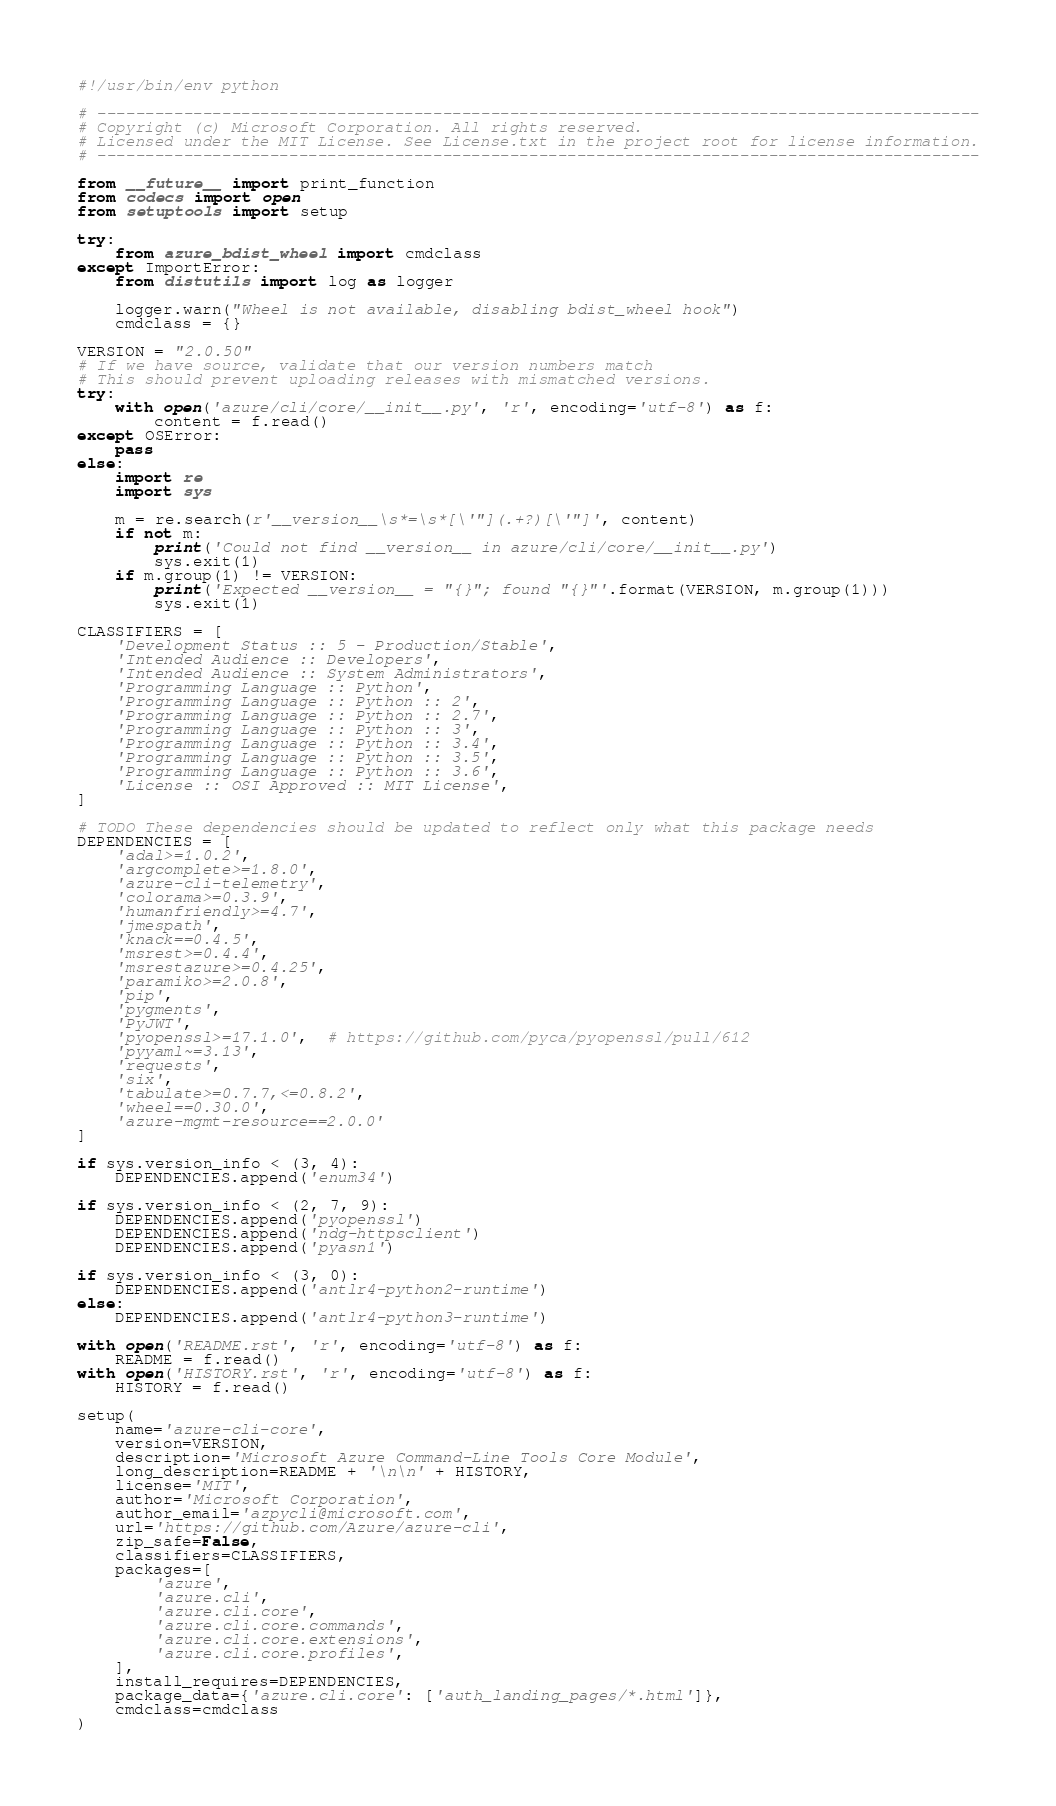<code> <loc_0><loc_0><loc_500><loc_500><_Python_>#!/usr/bin/env python

# --------------------------------------------------------------------------------------------
# Copyright (c) Microsoft Corporation. All rights reserved.
# Licensed under the MIT License. See License.txt in the project root for license information.
# --------------------------------------------------------------------------------------------

from __future__ import print_function
from codecs import open
from setuptools import setup

try:
    from azure_bdist_wheel import cmdclass
except ImportError:
    from distutils import log as logger

    logger.warn("Wheel is not available, disabling bdist_wheel hook")
    cmdclass = {}

VERSION = "2.0.50"
# If we have source, validate that our version numbers match
# This should prevent uploading releases with mismatched versions.
try:
    with open('azure/cli/core/__init__.py', 'r', encoding='utf-8') as f:
        content = f.read()
except OSError:
    pass
else:
    import re
    import sys

    m = re.search(r'__version__\s*=\s*[\'"](.+?)[\'"]', content)
    if not m:
        print('Could not find __version__ in azure/cli/core/__init__.py')
        sys.exit(1)
    if m.group(1) != VERSION:
        print('Expected __version__ = "{}"; found "{}"'.format(VERSION, m.group(1)))
        sys.exit(1)

CLASSIFIERS = [
    'Development Status :: 5 - Production/Stable',
    'Intended Audience :: Developers',
    'Intended Audience :: System Administrators',
    'Programming Language :: Python',
    'Programming Language :: Python :: 2',
    'Programming Language :: Python :: 2.7',
    'Programming Language :: Python :: 3',
    'Programming Language :: Python :: 3.4',
    'Programming Language :: Python :: 3.5',
    'Programming Language :: Python :: 3.6',
    'License :: OSI Approved :: MIT License',
]

# TODO These dependencies should be updated to reflect only what this package needs
DEPENDENCIES = [
    'adal>=1.0.2',
    'argcomplete>=1.8.0',
    'azure-cli-telemetry',
    'colorama>=0.3.9',
    'humanfriendly>=4.7',
    'jmespath',
    'knack==0.4.5',
    'msrest>=0.4.4',
    'msrestazure>=0.4.25',
    'paramiko>=2.0.8',
    'pip',
    'pygments',
    'PyJWT',
    'pyopenssl>=17.1.0',  # https://github.com/pyca/pyopenssl/pull/612
    'pyyaml~=3.13',
    'requests',
    'six',
    'tabulate>=0.7.7,<=0.8.2',
    'wheel==0.30.0',
    'azure-mgmt-resource==2.0.0'
]

if sys.version_info < (3, 4):
    DEPENDENCIES.append('enum34')

if sys.version_info < (2, 7, 9):
    DEPENDENCIES.append('pyopenssl')
    DEPENDENCIES.append('ndg-httpsclient')
    DEPENDENCIES.append('pyasn1')

if sys.version_info < (3, 0):
    DEPENDENCIES.append('antlr4-python2-runtime')
else:
    DEPENDENCIES.append('antlr4-python3-runtime')

with open('README.rst', 'r', encoding='utf-8') as f:
    README = f.read()
with open('HISTORY.rst', 'r', encoding='utf-8') as f:
    HISTORY = f.read()

setup(
    name='azure-cli-core',
    version=VERSION,
    description='Microsoft Azure Command-Line Tools Core Module',
    long_description=README + '\n\n' + HISTORY,
    license='MIT',
    author='Microsoft Corporation',
    author_email='azpycli@microsoft.com',
    url='https://github.com/Azure/azure-cli',
    zip_safe=False,
    classifiers=CLASSIFIERS,
    packages=[
        'azure',
        'azure.cli',
        'azure.cli.core',
        'azure.cli.core.commands',
        'azure.cli.core.extensions',
        'azure.cli.core.profiles',
    ],
    install_requires=DEPENDENCIES,
    package_data={'azure.cli.core': ['auth_landing_pages/*.html']},
    cmdclass=cmdclass
)
</code> 